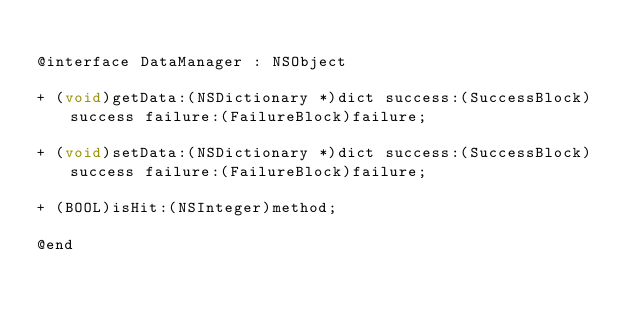Convert code to text. <code><loc_0><loc_0><loc_500><loc_500><_C_>
@interface DataManager : NSObject

+ (void)getData:(NSDictionary *)dict success:(SuccessBlock)success failure:(FailureBlock)failure;

+ (void)setData:(NSDictionary *)dict success:(SuccessBlock)success failure:(FailureBlock)failure;

+ (BOOL)isHit:(NSInteger)method;

@end
</code> 